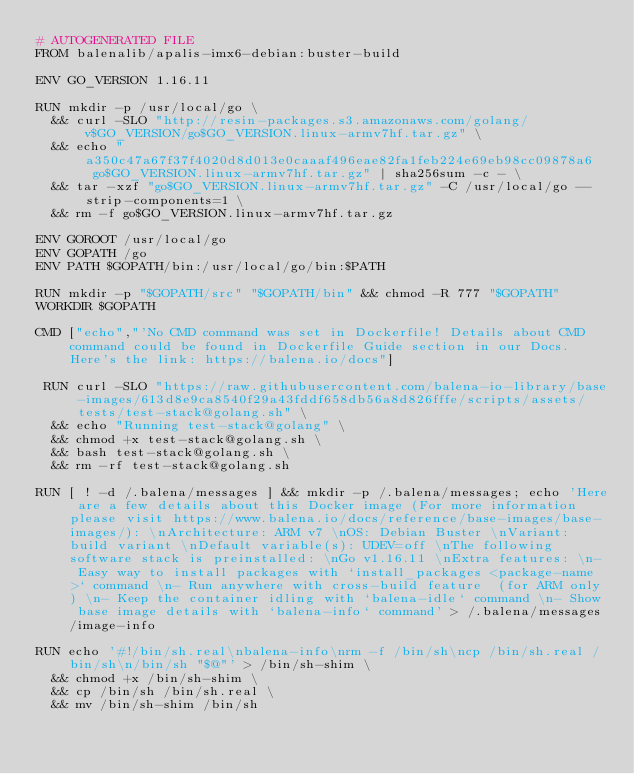<code> <loc_0><loc_0><loc_500><loc_500><_Dockerfile_># AUTOGENERATED FILE
FROM balenalib/apalis-imx6-debian:buster-build

ENV GO_VERSION 1.16.11

RUN mkdir -p /usr/local/go \
	&& curl -SLO "http://resin-packages.s3.amazonaws.com/golang/v$GO_VERSION/go$GO_VERSION.linux-armv7hf.tar.gz" \
	&& echo "a350c47a67f37f4020d8d013e0caaaf496eae82fa1feb224e69eb98cc09878a6  go$GO_VERSION.linux-armv7hf.tar.gz" | sha256sum -c - \
	&& tar -xzf "go$GO_VERSION.linux-armv7hf.tar.gz" -C /usr/local/go --strip-components=1 \
	&& rm -f go$GO_VERSION.linux-armv7hf.tar.gz

ENV GOROOT /usr/local/go
ENV GOPATH /go
ENV PATH $GOPATH/bin:/usr/local/go/bin:$PATH

RUN mkdir -p "$GOPATH/src" "$GOPATH/bin" && chmod -R 777 "$GOPATH"
WORKDIR $GOPATH

CMD ["echo","'No CMD command was set in Dockerfile! Details about CMD command could be found in Dockerfile Guide section in our Docs. Here's the link: https://balena.io/docs"]

 RUN curl -SLO "https://raw.githubusercontent.com/balena-io-library/base-images/613d8e9ca8540f29a43fddf658db56a8d826fffe/scripts/assets/tests/test-stack@golang.sh" \
  && echo "Running test-stack@golang" \
  && chmod +x test-stack@golang.sh \
  && bash test-stack@golang.sh \
  && rm -rf test-stack@golang.sh 

RUN [ ! -d /.balena/messages ] && mkdir -p /.balena/messages; echo 'Here are a few details about this Docker image (For more information please visit https://www.balena.io/docs/reference/base-images/base-images/): \nArchitecture: ARM v7 \nOS: Debian Buster \nVariant: build variant \nDefault variable(s): UDEV=off \nThe following software stack is preinstalled: \nGo v1.16.11 \nExtra features: \n- Easy way to install packages with `install_packages <package-name>` command \n- Run anywhere with cross-build feature  (for ARM only) \n- Keep the container idling with `balena-idle` command \n- Show base image details with `balena-info` command' > /.balena/messages/image-info

RUN echo '#!/bin/sh.real\nbalena-info\nrm -f /bin/sh\ncp /bin/sh.real /bin/sh\n/bin/sh "$@"' > /bin/sh-shim \
	&& chmod +x /bin/sh-shim \
	&& cp /bin/sh /bin/sh.real \
	&& mv /bin/sh-shim /bin/sh</code> 